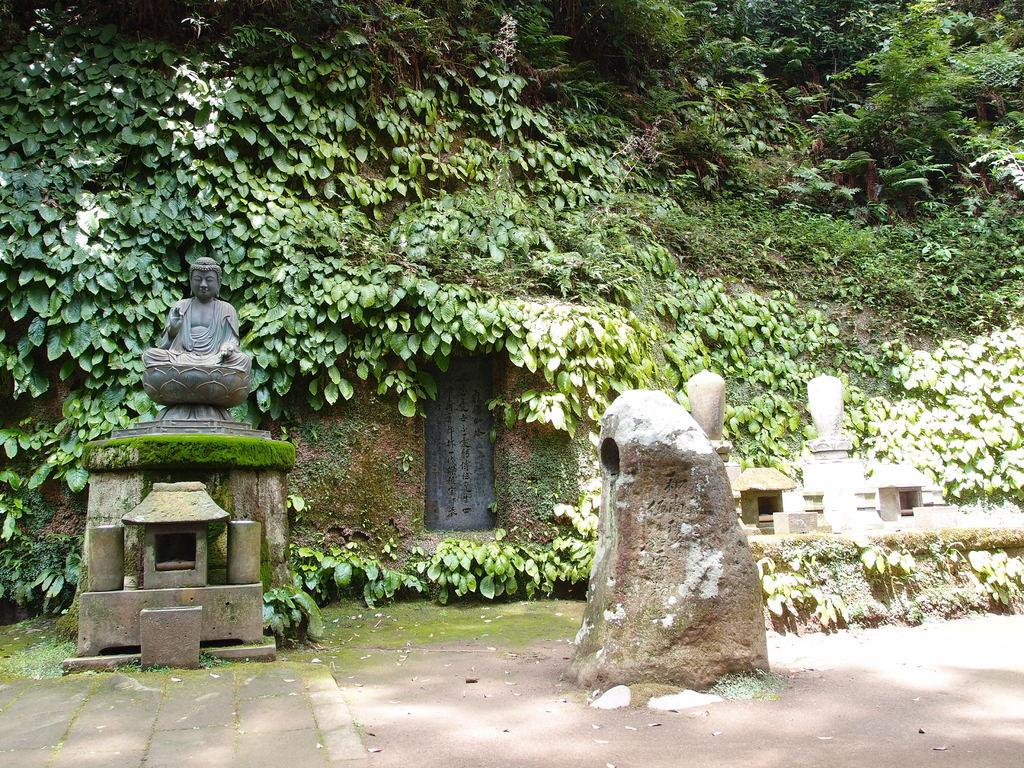What is the main subject in the image? There is a statue in the image. What type of vegetation can be seen in the image? There are green leaves and green trees in the image. What type of harmony can be heard in the image? There is no sound or music present in the image, so it is not possible to determine the type of harmony. 